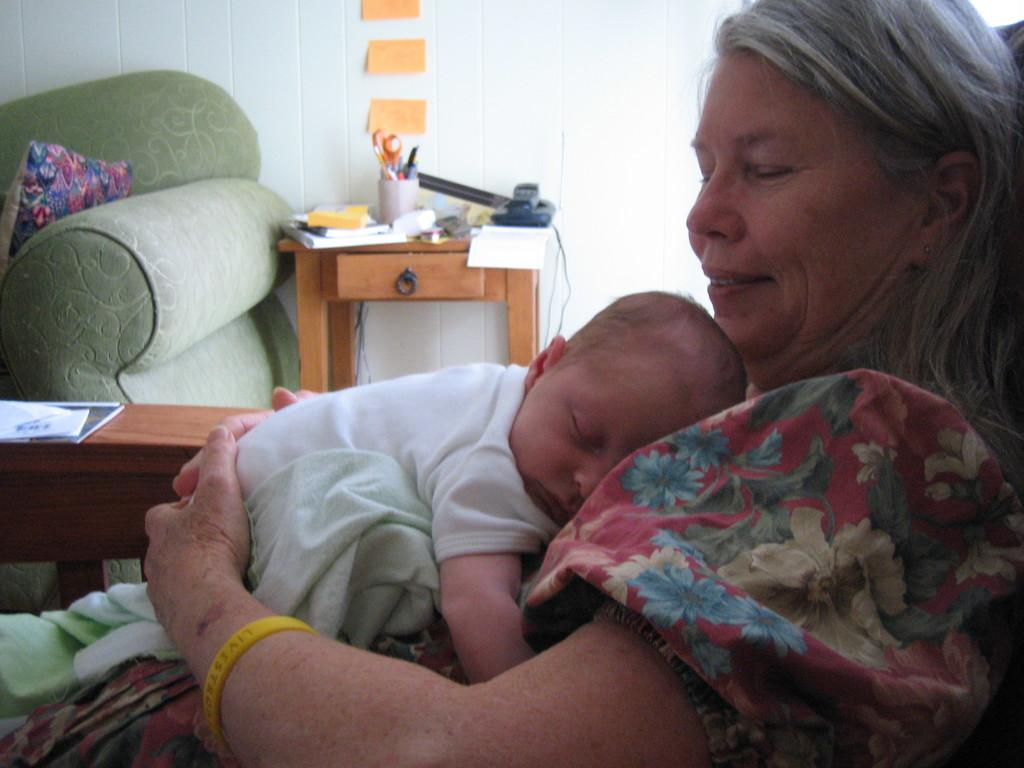Who is the main subject in the image? There is a woman in the image. What is the woman doing in the image? The woman is sitting in the image. What is on the woman? There is a baby on the woman. What can be seen in the background of the image? There is a wall, a table, and a couch in the background of the image. What is on the table in the background? There are items on the table in the background. What type of thunder can be heard in the image? There is no thunder present in the image, as it is a still photograph. Can you describe the spot on the sidewalk where the woman is sitting? There is no sidewalk present in the image; it is an indoor setting with a couch, table, and wall in the background. 